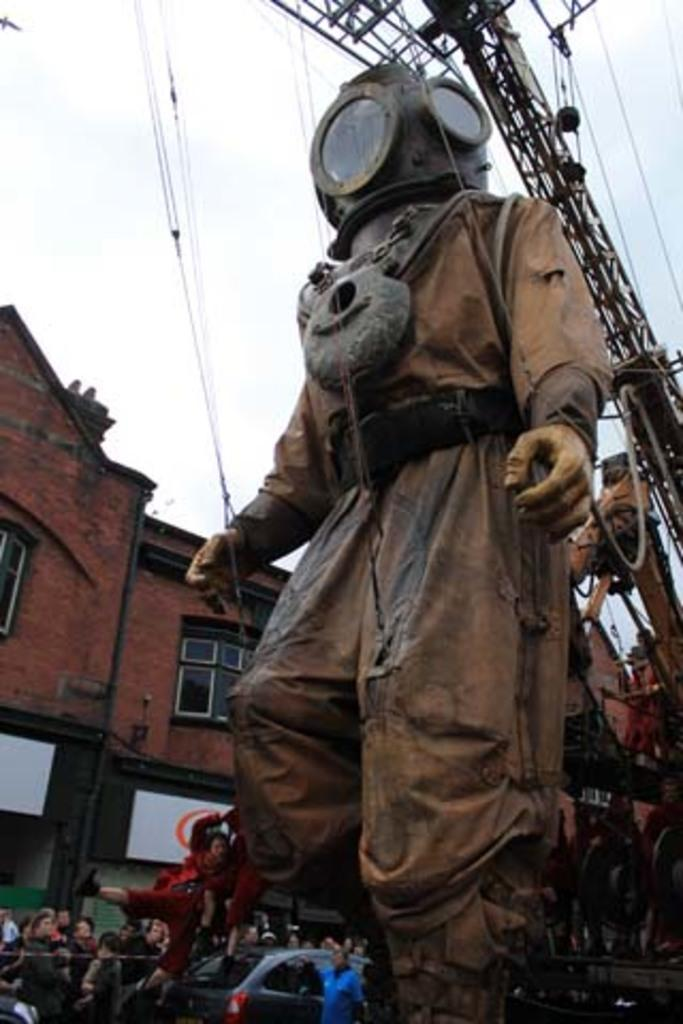Who or what can be seen in the image? There are people in the image. What is another object or structure present in the image? There is a statue in the image. What type of building is visible in the image? There is a house in the image. What feature of the house can be observed? The house has windows. What mode of transportation is present in the image? There is a vehicle in the image. Can you describe the type of vehicle? There is a car in the image. What part of the natural environment is visible in the image? The sky is visible in the image. What type of wrench is being used to teach the tooth in the image? There is no wrench or tooth present in the image. What subject is being taught by the people in the image? The image does not depict any teaching or educational activities. 